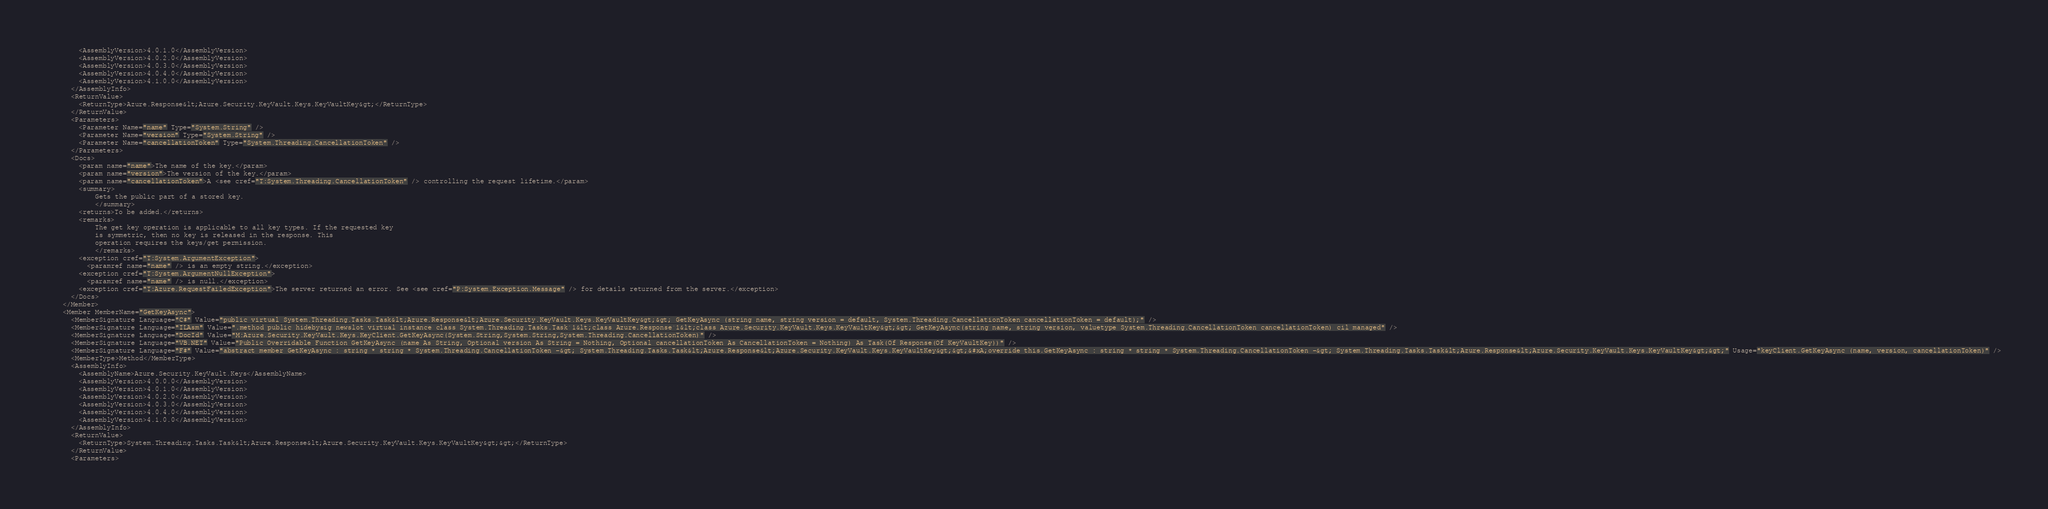Convert code to text. <code><loc_0><loc_0><loc_500><loc_500><_XML_>        <AssemblyVersion>4.0.1.0</AssemblyVersion>
        <AssemblyVersion>4.0.2.0</AssemblyVersion>
        <AssemblyVersion>4.0.3.0</AssemblyVersion>
        <AssemblyVersion>4.0.4.0</AssemblyVersion>
        <AssemblyVersion>4.1.0.0</AssemblyVersion>
      </AssemblyInfo>
      <ReturnValue>
        <ReturnType>Azure.Response&lt;Azure.Security.KeyVault.Keys.KeyVaultKey&gt;</ReturnType>
      </ReturnValue>
      <Parameters>
        <Parameter Name="name" Type="System.String" />
        <Parameter Name="version" Type="System.String" />
        <Parameter Name="cancellationToken" Type="System.Threading.CancellationToken" />
      </Parameters>
      <Docs>
        <param name="name">The name of the key.</param>
        <param name="version">The version of the key.</param>
        <param name="cancellationToken">A <see cref="T:System.Threading.CancellationToken" /> controlling the request lifetime.</param>
        <summary>
            Gets the public part of a stored key.
            </summary>
        <returns>To be added.</returns>
        <remarks>
            The get key operation is applicable to all key types. If the requested key
            is symmetric, then no key is released in the response. This
            operation requires the keys/get permission.
            </remarks>
        <exception cref="T:System.ArgumentException">
          <paramref name="name" /> is an empty string.</exception>
        <exception cref="T:System.ArgumentNullException">
          <paramref name="name" /> is null.</exception>
        <exception cref="T:Azure.RequestFailedException">The server returned an error. See <see cref="P:System.Exception.Message" /> for details returned from the server.</exception>
      </Docs>
    </Member>
    <Member MemberName="GetKeyAsync">
      <MemberSignature Language="C#" Value="public virtual System.Threading.Tasks.Task&lt;Azure.Response&lt;Azure.Security.KeyVault.Keys.KeyVaultKey&gt;&gt; GetKeyAsync (string name, string version = default, System.Threading.CancellationToken cancellationToken = default);" />
      <MemberSignature Language="ILAsm" Value=".method public hidebysig newslot virtual instance class System.Threading.Tasks.Task`1&lt;class Azure.Response`1&lt;class Azure.Security.KeyVault.Keys.KeyVaultKey&gt;&gt; GetKeyAsync(string name, string version, valuetype System.Threading.CancellationToken cancellationToken) cil managed" />
      <MemberSignature Language="DocId" Value="M:Azure.Security.KeyVault.Keys.KeyClient.GetKeyAsync(System.String,System.String,System.Threading.CancellationToken)" />
      <MemberSignature Language="VB.NET" Value="Public Overridable Function GetKeyAsync (name As String, Optional version As String = Nothing, Optional cancellationToken As CancellationToken = Nothing) As Task(Of Response(Of KeyVaultKey))" />
      <MemberSignature Language="F#" Value="abstract member GetKeyAsync : string * string * System.Threading.CancellationToken -&gt; System.Threading.Tasks.Task&lt;Azure.Response&lt;Azure.Security.KeyVault.Keys.KeyVaultKey&gt;&gt;&#xA;override this.GetKeyAsync : string * string * System.Threading.CancellationToken -&gt; System.Threading.Tasks.Task&lt;Azure.Response&lt;Azure.Security.KeyVault.Keys.KeyVaultKey&gt;&gt;" Usage="keyClient.GetKeyAsync (name, version, cancellationToken)" />
      <MemberType>Method</MemberType>
      <AssemblyInfo>
        <AssemblyName>Azure.Security.KeyVault.Keys</AssemblyName>
        <AssemblyVersion>4.0.0.0</AssemblyVersion>
        <AssemblyVersion>4.0.1.0</AssemblyVersion>
        <AssemblyVersion>4.0.2.0</AssemblyVersion>
        <AssemblyVersion>4.0.3.0</AssemblyVersion>
        <AssemblyVersion>4.0.4.0</AssemblyVersion>
        <AssemblyVersion>4.1.0.0</AssemblyVersion>
      </AssemblyInfo>
      <ReturnValue>
        <ReturnType>System.Threading.Tasks.Task&lt;Azure.Response&lt;Azure.Security.KeyVault.Keys.KeyVaultKey&gt;&gt;</ReturnType>
      </ReturnValue>
      <Parameters></code> 